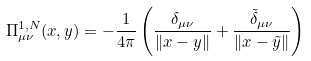<formula> <loc_0><loc_0><loc_500><loc_500>\Pi ^ { 1 , N } _ { \mu \nu } ( x , y ) = - \frac { 1 } { 4 \pi } \left ( \frac { \delta _ { \mu \nu } } { \| x - y \| } + \frac { \tilde { \delta } _ { \mu \nu } } { \| x - \tilde { y } \| } \right )</formula> 